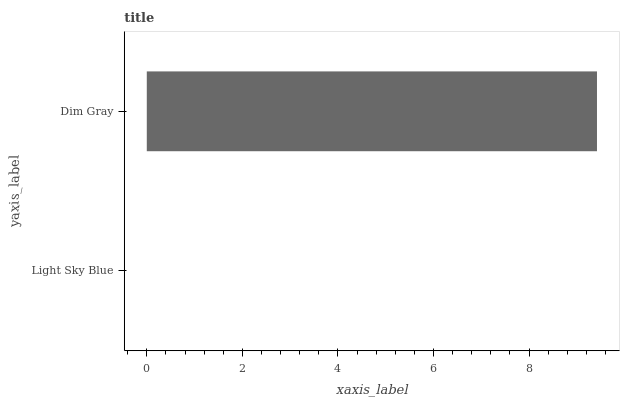Is Light Sky Blue the minimum?
Answer yes or no. Yes. Is Dim Gray the maximum?
Answer yes or no. Yes. Is Dim Gray the minimum?
Answer yes or no. No. Is Dim Gray greater than Light Sky Blue?
Answer yes or no. Yes. Is Light Sky Blue less than Dim Gray?
Answer yes or no. Yes. Is Light Sky Blue greater than Dim Gray?
Answer yes or no. No. Is Dim Gray less than Light Sky Blue?
Answer yes or no. No. Is Dim Gray the high median?
Answer yes or no. Yes. Is Light Sky Blue the low median?
Answer yes or no. Yes. Is Light Sky Blue the high median?
Answer yes or no. No. Is Dim Gray the low median?
Answer yes or no. No. 